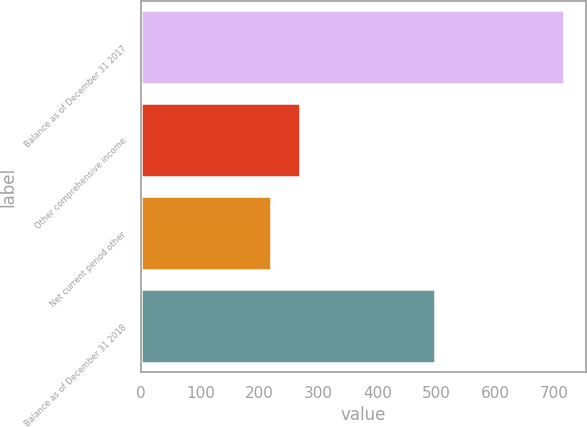Convert chart to OTSL. <chart><loc_0><loc_0><loc_500><loc_500><bar_chart><fcel>Balance as of December 31 2017<fcel>Other comprehensive income<fcel>Net current period other<fcel>Balance as of December 31 2018<nl><fcel>717<fcel>268.8<fcel>219<fcel>498<nl></chart> 